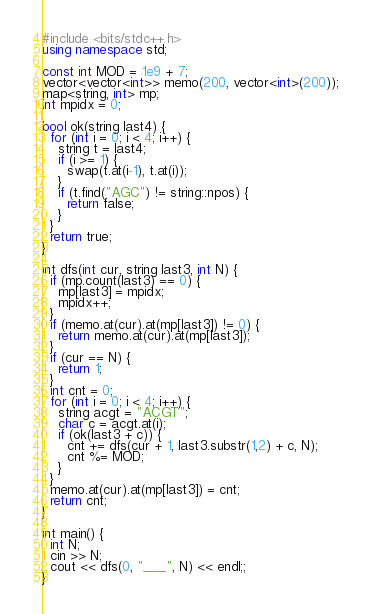Convert code to text. <code><loc_0><loc_0><loc_500><loc_500><_C++_>#include <bits/stdc++.h>
using namespace std;

const int MOD = 1e9 + 7;
vector<vector<int>> memo(200, vector<int>(200));
map<string, int> mp;
int mpidx = 0;

bool ok(string last4) {
  for (int i = 0; i < 4; i++) {
    string t = last4;
    if (i >= 1) {
      swap(t.at(i-1), t.at(i));
    }
    if (t.find("AGC") != string::npos) {
      return false;
    }
  }
  return true;
}

int dfs(int cur, string last3, int N) {
  if (mp.count(last3) == 0) {
    mp[last3] = mpidx;
    mpidx++;
  }
  if (memo.at(cur).at(mp[last3]) != 0) {
    return memo.at(cur).at(mp[last3]);
  }
  if (cur == N) {
    return 1;
  }
  int cnt = 0;
  for (int i = 0; i < 4; i++) {
    string acgt = "ACGT";
    char c = acgt.at(i);
    if (ok(last3 + c)) {
      cnt += dfs(cur + 1, last3.substr(1,2) + c, N);
      cnt %= MOD;
    }
  }
  memo.at(cur).at(mp[last3]) = cnt;
  return cnt;
}

int main() {
  int N;
  cin >> N;
  cout << dfs(0, "___", N) << endl;;
}</code> 